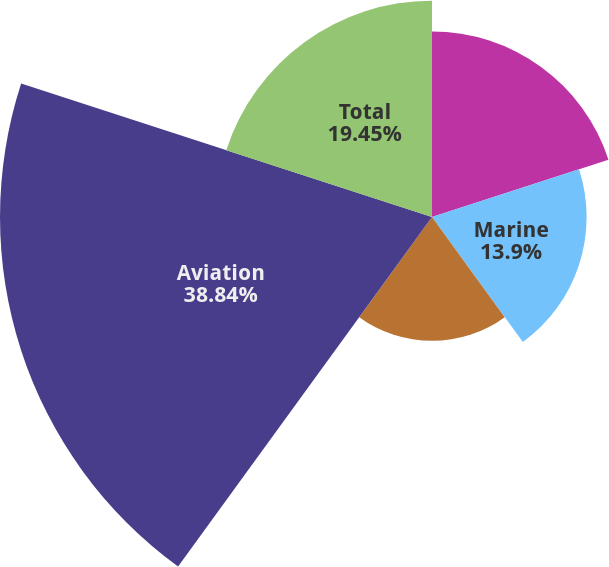Convert chart to OTSL. <chart><loc_0><loc_0><loc_500><loc_500><pie_chart><fcel>Outdoor/Fitness<fcel>Marine<fcel>Automotive/Mobile<fcel>Aviation<fcel>Total<nl><fcel>16.68%<fcel>13.9%<fcel>11.13%<fcel>38.84%<fcel>19.45%<nl></chart> 